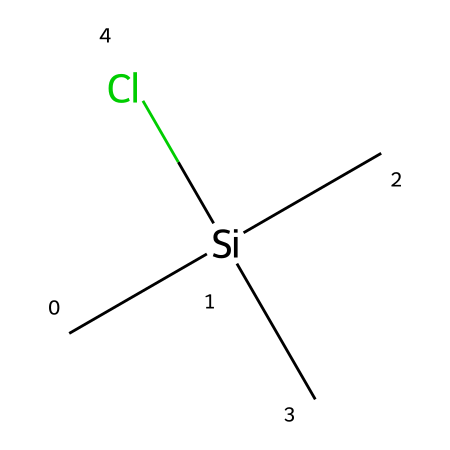What is the central atom in this chemical structure? The central atom can be identified by its connectivity in the structure. In the provided SMILES, "C[Si](C)(C)Cl" indicates that silicon (Si) is the atom that connects to three methyl (C) groups and one chlorine (Cl) atom.
Answer: silicon How many carbon atoms are present in this molecule? By examining the SMILES notation, we see three "C" atoms listed near the central silicon atom along with one additional carbon that is alphabetically represented within the parentheses. Thus, there are a total of four carbon atoms in the structure.
Answer: four What type of bonds are present between the silicon and surrounding atoms? The structure indicates that silicon is bonded to three carbon atoms and one chlorine atom, which are all single covalent bonds (as per common valency of Si) since the notation does not indicate any multiple bonds.
Answer: single What functional group is indicated by the presence of chlorine in this chemical? The chlorine atom indicates the presence of a halogen functional group, which in this case can be classified as a chloro group due to the specific chlorine attachment to the silicon center.
Answer: chloro What is the hybridization of the silicon atom in this monomer? Silicon, in this structure, is bonded to four other atoms (three carbons and one chlorine). This hybridization corresponds to sp3 hybridization which is suitable for four single bonds.
Answer: sp3 What is the expected state of this silicon monomer at room temperature? Given that the monomer contains predominantly carbon and silicon, both of which are typically solid at room temperature, and considering the lack of features that suggest volatility or low melting point, we can conclude that it is likely a solid.
Answer: solid 